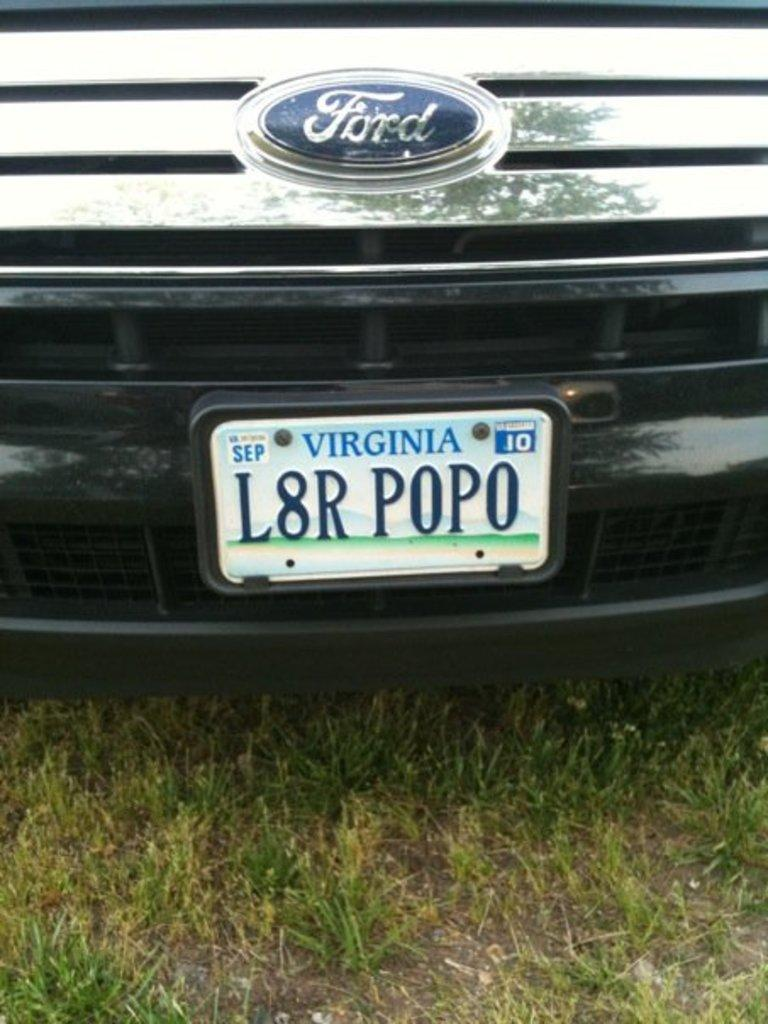<image>
Describe the image concisely. The Virginia license plate on the Ford vehicle is labeled as 'L8R POPO'. 